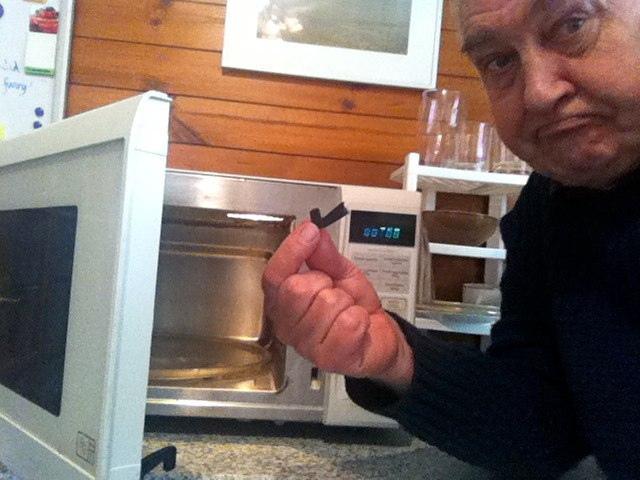What does the man hold?
Select the accurate answer and provide explanation: 'Answer: answer
Rationale: rationale.'
Options: Check mark, glasses, microwave part, dishes. Answer: microwave part.
Rationale: He is standing near a microwave.  there is a piece of plastic in his hand. 